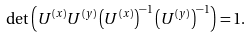<formula> <loc_0><loc_0><loc_500><loc_500>\det \left ( U ^ { ( x ) } U ^ { ( y ) } \left ( U ^ { ( x ) } \right ) ^ { - 1 } \left ( U ^ { ( y ) } \right ) ^ { - 1 } \right ) = 1 .</formula> 